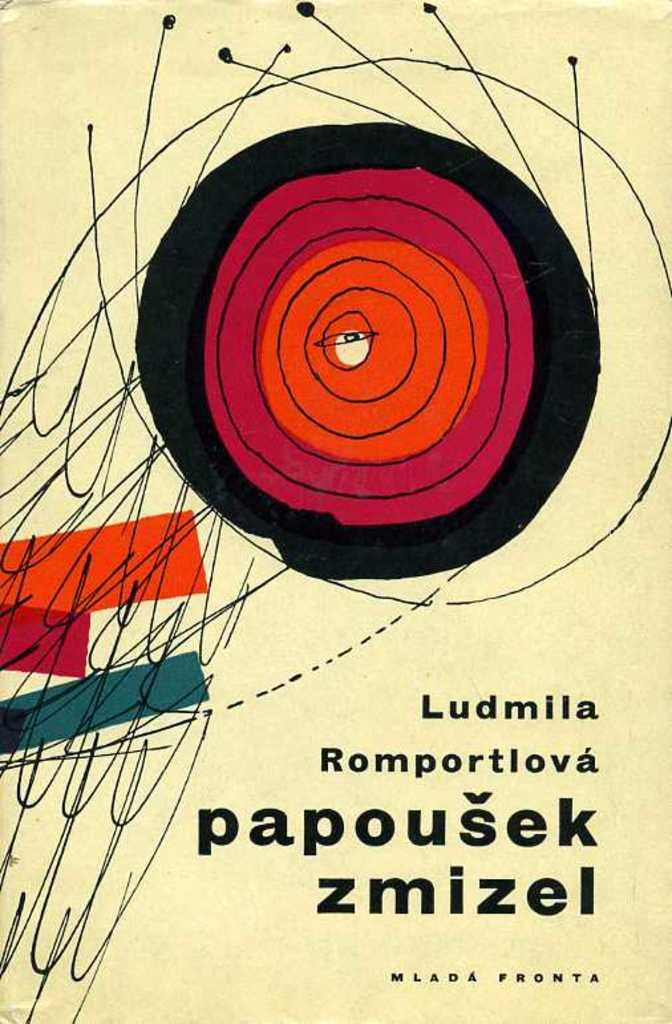What is the full title name?
Give a very brief answer. Papousek zmizel. What is the first letter of the title?
Your response must be concise. P. 